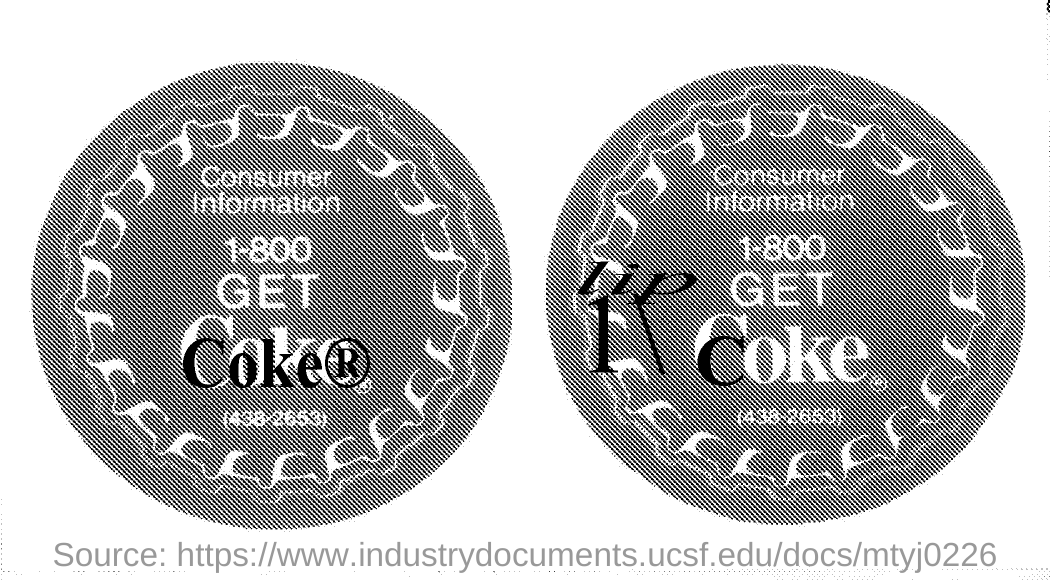Outline some significant characteristics in this image. The word written in bold black in the first picture is 'Coke ®'. 